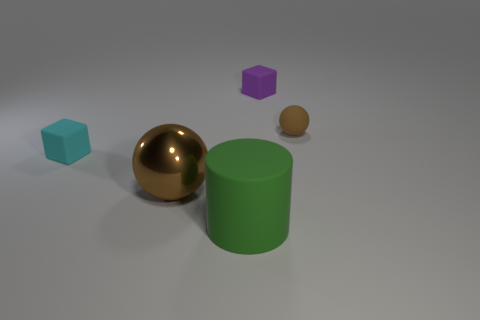Is the color of the sphere that is on the left side of the tiny brown ball the same as the tiny matte sphere?
Your response must be concise. Yes. Are there any other things that have the same color as the matte ball?
Your answer should be very brief. Yes. What is the color of the matte object to the right of the tiny block that is on the right side of the big object left of the cylinder?
Keep it short and to the point. Brown. Is the purple matte object the same size as the cyan thing?
Your response must be concise. Yes. How many cyan rubber objects are the same size as the brown matte sphere?
Provide a succinct answer. 1. The thing that is the same color as the small ball is what shape?
Your answer should be very brief. Sphere. Are the small brown thing that is behind the metal thing and the small block that is to the left of the green thing made of the same material?
Give a very brief answer. Yes. Is there anything else that is the same shape as the large green matte object?
Keep it short and to the point. No. The large shiny object is what color?
Keep it short and to the point. Brown. What number of brown metal objects have the same shape as the small brown matte thing?
Give a very brief answer. 1. 